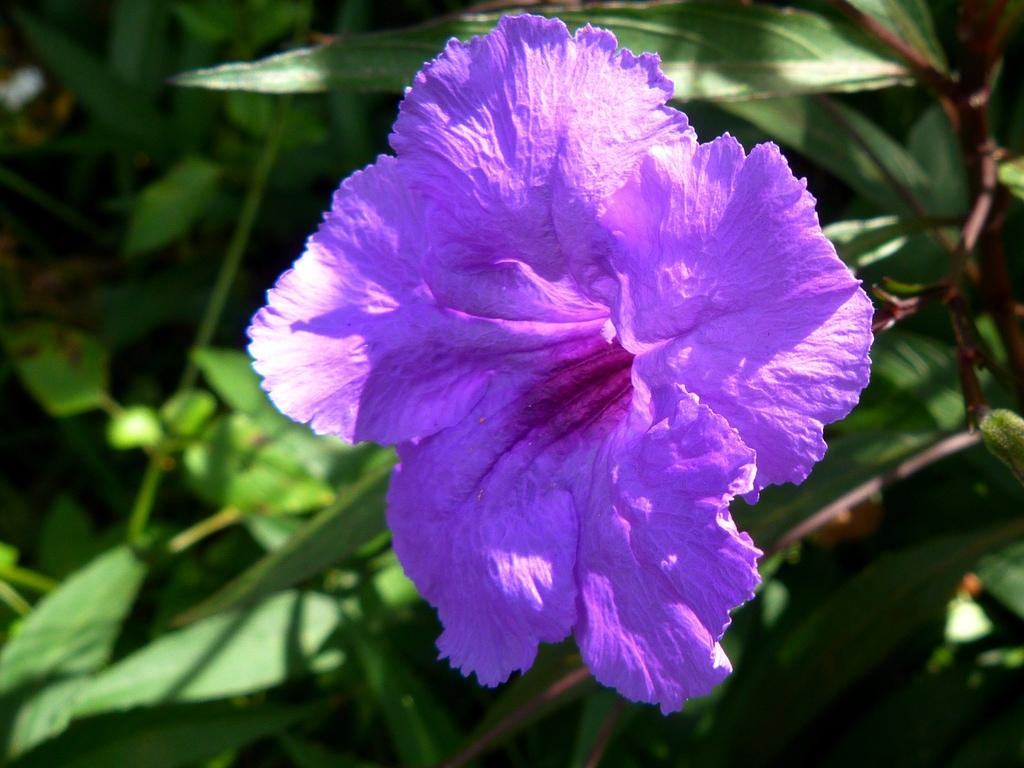What color is the flower in the image? The flower in the image is purple. What other elements can be seen in the image besides the flower? There are green leaves in the image. What type of vest is the flower wearing in the image? There is no vest present in the image, as flowers do not wear clothing. 